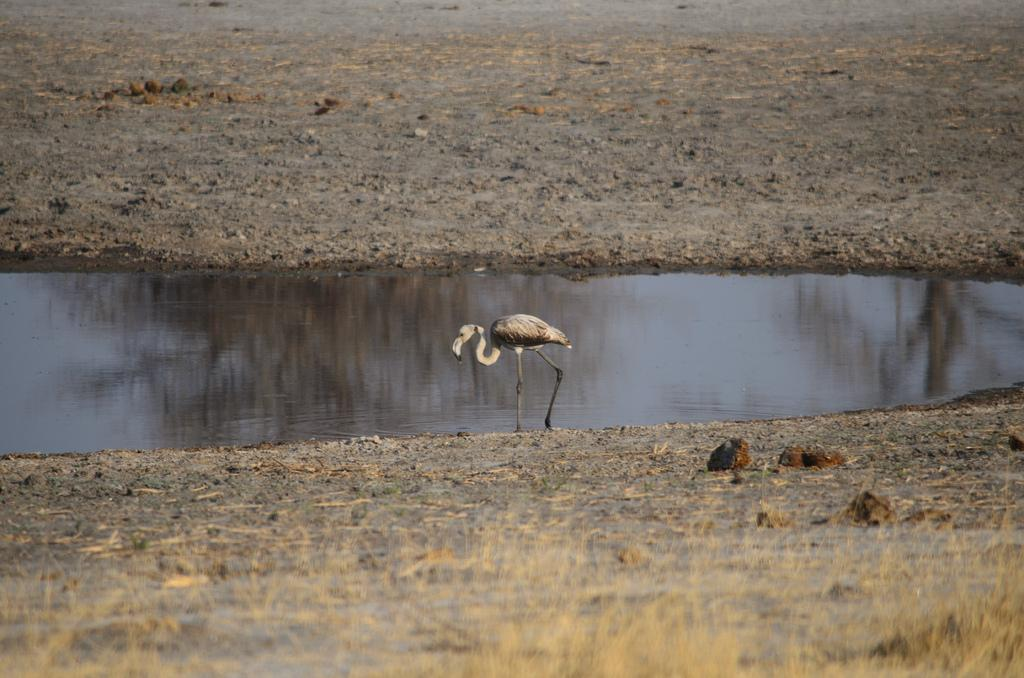What is the main subject of the image? There is a crane in the image. What is the crane doing in the image? The crane is walking on the ground. What can be seen in the background of the image? There is water visible in the image. What type of terrain is present in the image? There are stones and grass on the ground. What type of spy equipment can be seen in the image? There is no spy equipment present in the image; it features a crane walking on the ground with water, stones, and grass in the background. Is there a camp or gate visible in the image? No, there is no camp or gate present in the image. 